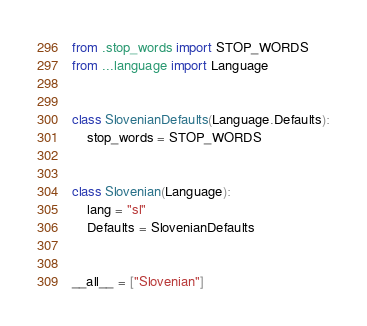<code> <loc_0><loc_0><loc_500><loc_500><_Python_>from .stop_words import STOP_WORDS
from ...language import Language


class SlovenianDefaults(Language.Defaults):
    stop_words = STOP_WORDS


class Slovenian(Language):
    lang = "sl"
    Defaults = SlovenianDefaults


__all__ = ["Slovenian"]
</code> 